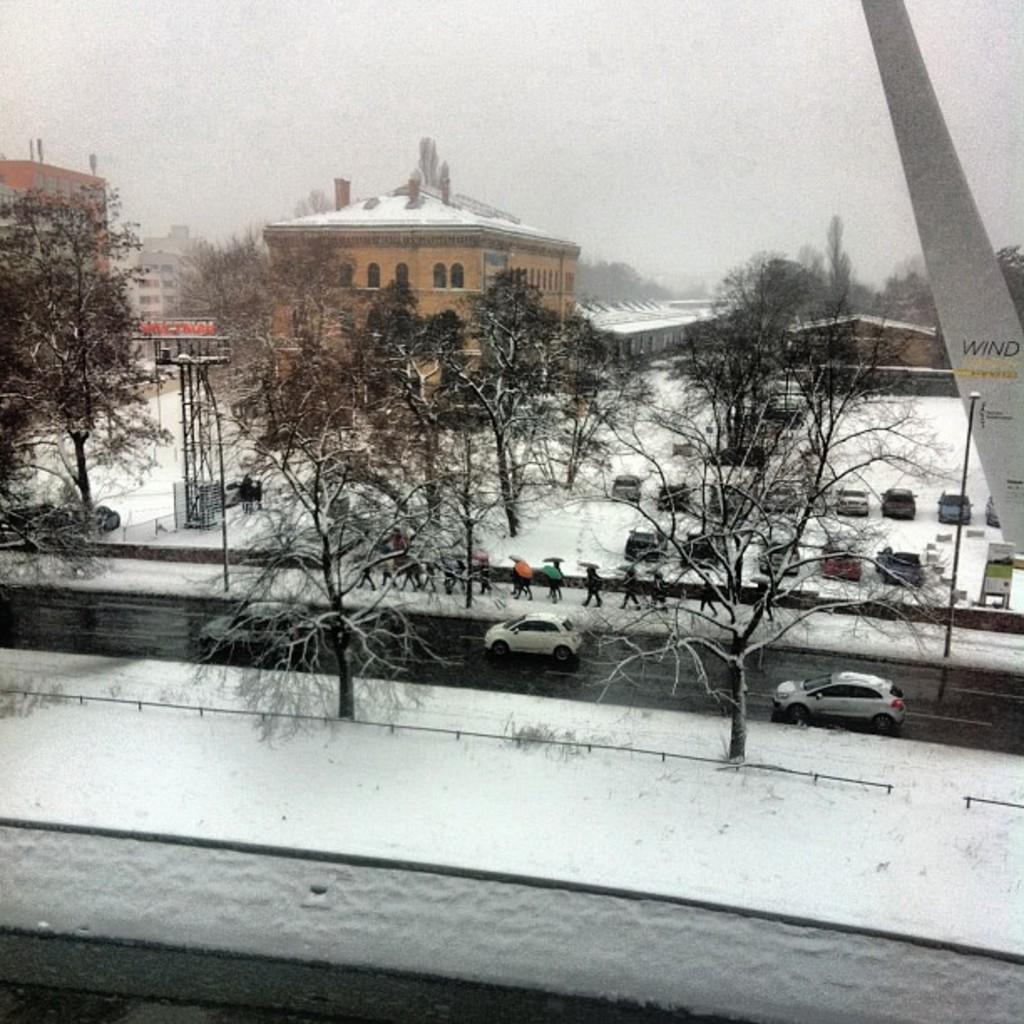What types of objects can be seen in the image? There are vehicles, poles, trees, and buildings in the image. Can you describe the people in the image? There is a group of people in the image, and they are walking on a pathway. What is the weather like in the image? There is snow visible in the image, indicating a cold or wintery environment. How does the group of people reward the trees in the image? There is no indication in the image that the group of people is rewarding the trees, as trees do not require rewards. 